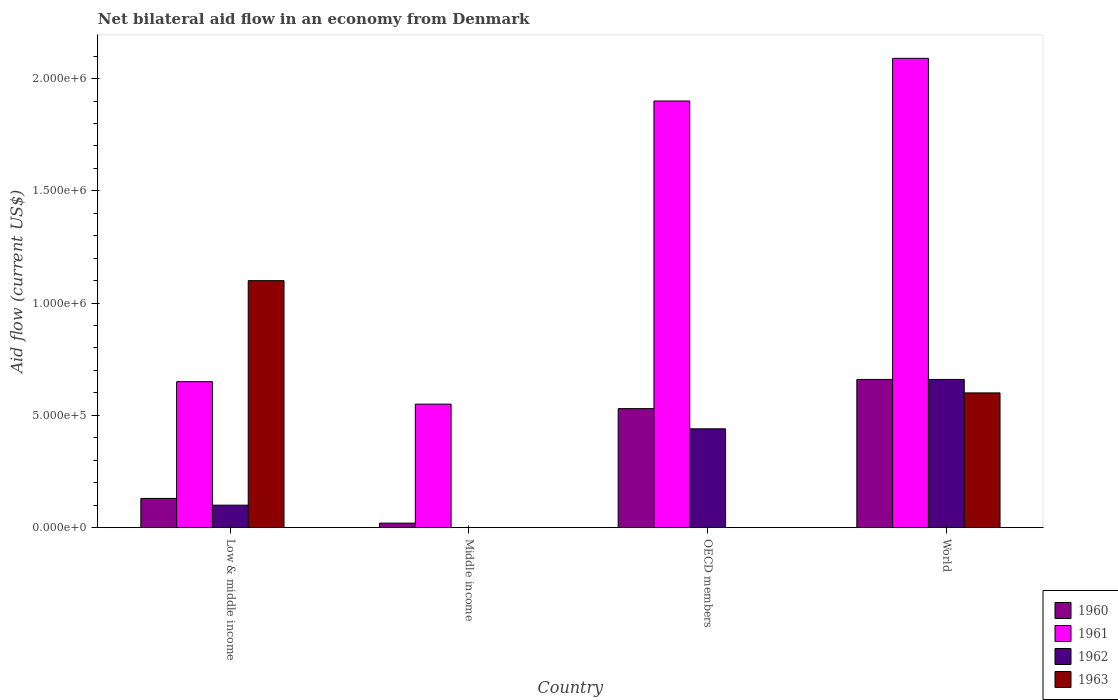Are the number of bars per tick equal to the number of legend labels?
Make the answer very short. No. How many bars are there on the 2nd tick from the right?
Provide a succinct answer. 3. In how many cases, is the number of bars for a given country not equal to the number of legend labels?
Your answer should be compact. 2. What is the net bilateral aid flow in 1960 in Low & middle income?
Offer a very short reply. 1.30e+05. Across all countries, what is the minimum net bilateral aid flow in 1960?
Give a very brief answer. 2.00e+04. In which country was the net bilateral aid flow in 1960 maximum?
Your answer should be very brief. World. What is the total net bilateral aid flow in 1960 in the graph?
Offer a terse response. 1.34e+06. What is the difference between the net bilateral aid flow in 1960 in Middle income and that in OECD members?
Ensure brevity in your answer.  -5.10e+05. What is the difference between the net bilateral aid flow in 1960 in Middle income and the net bilateral aid flow in 1963 in World?
Offer a very short reply. -5.80e+05. What is the average net bilateral aid flow in 1961 per country?
Your response must be concise. 1.30e+06. What is the difference between the net bilateral aid flow of/in 1960 and net bilateral aid flow of/in 1962 in Low & middle income?
Provide a short and direct response. 3.00e+04. In how many countries, is the net bilateral aid flow in 1960 greater than 1200000 US$?
Make the answer very short. 0. What is the ratio of the net bilateral aid flow in 1960 in Low & middle income to that in World?
Your response must be concise. 0.2. Is the net bilateral aid flow in 1960 in Low & middle income less than that in OECD members?
Your answer should be very brief. Yes. What is the difference between the highest and the second highest net bilateral aid flow in 1961?
Provide a succinct answer. 1.44e+06. What is the difference between the highest and the lowest net bilateral aid flow in 1962?
Offer a terse response. 6.60e+05. In how many countries, is the net bilateral aid flow in 1963 greater than the average net bilateral aid flow in 1963 taken over all countries?
Make the answer very short. 2. Is it the case that in every country, the sum of the net bilateral aid flow in 1960 and net bilateral aid flow in 1962 is greater than the sum of net bilateral aid flow in 1961 and net bilateral aid flow in 1963?
Ensure brevity in your answer.  No. Is it the case that in every country, the sum of the net bilateral aid flow in 1961 and net bilateral aid flow in 1960 is greater than the net bilateral aid flow in 1962?
Your answer should be compact. Yes. How many bars are there?
Give a very brief answer. 13. Are all the bars in the graph horizontal?
Ensure brevity in your answer.  No. How many countries are there in the graph?
Offer a terse response. 4. What is the difference between two consecutive major ticks on the Y-axis?
Ensure brevity in your answer.  5.00e+05. What is the title of the graph?
Your response must be concise. Net bilateral aid flow in an economy from Denmark. What is the Aid flow (current US$) in 1960 in Low & middle income?
Make the answer very short. 1.30e+05. What is the Aid flow (current US$) of 1961 in Low & middle income?
Ensure brevity in your answer.  6.50e+05. What is the Aid flow (current US$) in 1962 in Low & middle income?
Make the answer very short. 1.00e+05. What is the Aid flow (current US$) of 1963 in Low & middle income?
Provide a succinct answer. 1.10e+06. What is the Aid flow (current US$) of 1960 in OECD members?
Provide a succinct answer. 5.30e+05. What is the Aid flow (current US$) of 1961 in OECD members?
Offer a terse response. 1.90e+06. What is the Aid flow (current US$) of 1962 in OECD members?
Keep it short and to the point. 4.40e+05. What is the Aid flow (current US$) in 1963 in OECD members?
Your answer should be compact. 0. What is the Aid flow (current US$) in 1961 in World?
Provide a succinct answer. 2.09e+06. Across all countries, what is the maximum Aid flow (current US$) of 1960?
Keep it short and to the point. 6.60e+05. Across all countries, what is the maximum Aid flow (current US$) of 1961?
Your response must be concise. 2.09e+06. Across all countries, what is the maximum Aid flow (current US$) in 1963?
Make the answer very short. 1.10e+06. Across all countries, what is the minimum Aid flow (current US$) of 1960?
Ensure brevity in your answer.  2.00e+04. Across all countries, what is the minimum Aid flow (current US$) in 1961?
Your response must be concise. 5.50e+05. Across all countries, what is the minimum Aid flow (current US$) in 1962?
Provide a short and direct response. 0. Across all countries, what is the minimum Aid flow (current US$) in 1963?
Provide a short and direct response. 0. What is the total Aid flow (current US$) of 1960 in the graph?
Ensure brevity in your answer.  1.34e+06. What is the total Aid flow (current US$) of 1961 in the graph?
Make the answer very short. 5.19e+06. What is the total Aid flow (current US$) in 1962 in the graph?
Provide a succinct answer. 1.20e+06. What is the total Aid flow (current US$) of 1963 in the graph?
Your answer should be very brief. 1.70e+06. What is the difference between the Aid flow (current US$) in 1960 in Low & middle income and that in Middle income?
Your answer should be very brief. 1.10e+05. What is the difference between the Aid flow (current US$) of 1960 in Low & middle income and that in OECD members?
Your answer should be very brief. -4.00e+05. What is the difference between the Aid flow (current US$) of 1961 in Low & middle income and that in OECD members?
Provide a succinct answer. -1.25e+06. What is the difference between the Aid flow (current US$) of 1960 in Low & middle income and that in World?
Offer a very short reply. -5.30e+05. What is the difference between the Aid flow (current US$) in 1961 in Low & middle income and that in World?
Provide a succinct answer. -1.44e+06. What is the difference between the Aid flow (current US$) of 1962 in Low & middle income and that in World?
Provide a succinct answer. -5.60e+05. What is the difference between the Aid flow (current US$) of 1963 in Low & middle income and that in World?
Your answer should be compact. 5.00e+05. What is the difference between the Aid flow (current US$) in 1960 in Middle income and that in OECD members?
Your answer should be very brief. -5.10e+05. What is the difference between the Aid flow (current US$) of 1961 in Middle income and that in OECD members?
Make the answer very short. -1.35e+06. What is the difference between the Aid flow (current US$) in 1960 in Middle income and that in World?
Make the answer very short. -6.40e+05. What is the difference between the Aid flow (current US$) in 1961 in Middle income and that in World?
Provide a short and direct response. -1.54e+06. What is the difference between the Aid flow (current US$) of 1960 in Low & middle income and the Aid flow (current US$) of 1961 in Middle income?
Ensure brevity in your answer.  -4.20e+05. What is the difference between the Aid flow (current US$) in 1960 in Low & middle income and the Aid flow (current US$) in 1961 in OECD members?
Provide a short and direct response. -1.77e+06. What is the difference between the Aid flow (current US$) of 1960 in Low & middle income and the Aid flow (current US$) of 1962 in OECD members?
Your answer should be compact. -3.10e+05. What is the difference between the Aid flow (current US$) in 1961 in Low & middle income and the Aid flow (current US$) in 1962 in OECD members?
Give a very brief answer. 2.10e+05. What is the difference between the Aid flow (current US$) of 1960 in Low & middle income and the Aid flow (current US$) of 1961 in World?
Provide a succinct answer. -1.96e+06. What is the difference between the Aid flow (current US$) in 1960 in Low & middle income and the Aid flow (current US$) in 1962 in World?
Your answer should be compact. -5.30e+05. What is the difference between the Aid flow (current US$) in 1960 in Low & middle income and the Aid flow (current US$) in 1963 in World?
Keep it short and to the point. -4.70e+05. What is the difference between the Aid flow (current US$) in 1962 in Low & middle income and the Aid flow (current US$) in 1963 in World?
Your answer should be compact. -5.00e+05. What is the difference between the Aid flow (current US$) in 1960 in Middle income and the Aid flow (current US$) in 1961 in OECD members?
Your answer should be compact. -1.88e+06. What is the difference between the Aid flow (current US$) in 1960 in Middle income and the Aid flow (current US$) in 1962 in OECD members?
Provide a succinct answer. -4.20e+05. What is the difference between the Aid flow (current US$) of 1961 in Middle income and the Aid flow (current US$) of 1962 in OECD members?
Make the answer very short. 1.10e+05. What is the difference between the Aid flow (current US$) in 1960 in Middle income and the Aid flow (current US$) in 1961 in World?
Your answer should be compact. -2.07e+06. What is the difference between the Aid flow (current US$) in 1960 in Middle income and the Aid flow (current US$) in 1962 in World?
Your answer should be compact. -6.40e+05. What is the difference between the Aid flow (current US$) of 1960 in Middle income and the Aid flow (current US$) of 1963 in World?
Provide a short and direct response. -5.80e+05. What is the difference between the Aid flow (current US$) of 1961 in Middle income and the Aid flow (current US$) of 1963 in World?
Provide a short and direct response. -5.00e+04. What is the difference between the Aid flow (current US$) in 1960 in OECD members and the Aid flow (current US$) in 1961 in World?
Keep it short and to the point. -1.56e+06. What is the difference between the Aid flow (current US$) of 1960 in OECD members and the Aid flow (current US$) of 1962 in World?
Ensure brevity in your answer.  -1.30e+05. What is the difference between the Aid flow (current US$) of 1961 in OECD members and the Aid flow (current US$) of 1962 in World?
Give a very brief answer. 1.24e+06. What is the difference between the Aid flow (current US$) of 1961 in OECD members and the Aid flow (current US$) of 1963 in World?
Your answer should be very brief. 1.30e+06. What is the average Aid flow (current US$) of 1960 per country?
Keep it short and to the point. 3.35e+05. What is the average Aid flow (current US$) in 1961 per country?
Offer a very short reply. 1.30e+06. What is the average Aid flow (current US$) in 1962 per country?
Your answer should be compact. 3.00e+05. What is the average Aid flow (current US$) in 1963 per country?
Your answer should be very brief. 4.25e+05. What is the difference between the Aid flow (current US$) of 1960 and Aid flow (current US$) of 1961 in Low & middle income?
Offer a very short reply. -5.20e+05. What is the difference between the Aid flow (current US$) in 1960 and Aid flow (current US$) in 1963 in Low & middle income?
Your answer should be very brief. -9.70e+05. What is the difference between the Aid flow (current US$) of 1961 and Aid flow (current US$) of 1962 in Low & middle income?
Make the answer very short. 5.50e+05. What is the difference between the Aid flow (current US$) in 1961 and Aid flow (current US$) in 1963 in Low & middle income?
Provide a succinct answer. -4.50e+05. What is the difference between the Aid flow (current US$) of 1960 and Aid flow (current US$) of 1961 in Middle income?
Your answer should be very brief. -5.30e+05. What is the difference between the Aid flow (current US$) of 1960 and Aid flow (current US$) of 1961 in OECD members?
Offer a terse response. -1.37e+06. What is the difference between the Aid flow (current US$) in 1961 and Aid flow (current US$) in 1962 in OECD members?
Give a very brief answer. 1.46e+06. What is the difference between the Aid flow (current US$) of 1960 and Aid flow (current US$) of 1961 in World?
Keep it short and to the point. -1.43e+06. What is the difference between the Aid flow (current US$) in 1960 and Aid flow (current US$) in 1963 in World?
Provide a short and direct response. 6.00e+04. What is the difference between the Aid flow (current US$) of 1961 and Aid flow (current US$) of 1962 in World?
Provide a short and direct response. 1.43e+06. What is the difference between the Aid flow (current US$) of 1961 and Aid flow (current US$) of 1963 in World?
Your response must be concise. 1.49e+06. What is the ratio of the Aid flow (current US$) of 1960 in Low & middle income to that in Middle income?
Keep it short and to the point. 6.5. What is the ratio of the Aid flow (current US$) in 1961 in Low & middle income to that in Middle income?
Your answer should be compact. 1.18. What is the ratio of the Aid flow (current US$) of 1960 in Low & middle income to that in OECD members?
Give a very brief answer. 0.25. What is the ratio of the Aid flow (current US$) in 1961 in Low & middle income to that in OECD members?
Your answer should be compact. 0.34. What is the ratio of the Aid flow (current US$) in 1962 in Low & middle income to that in OECD members?
Your answer should be very brief. 0.23. What is the ratio of the Aid flow (current US$) of 1960 in Low & middle income to that in World?
Give a very brief answer. 0.2. What is the ratio of the Aid flow (current US$) in 1961 in Low & middle income to that in World?
Your answer should be compact. 0.31. What is the ratio of the Aid flow (current US$) in 1962 in Low & middle income to that in World?
Offer a terse response. 0.15. What is the ratio of the Aid flow (current US$) of 1963 in Low & middle income to that in World?
Make the answer very short. 1.83. What is the ratio of the Aid flow (current US$) of 1960 in Middle income to that in OECD members?
Your answer should be very brief. 0.04. What is the ratio of the Aid flow (current US$) in 1961 in Middle income to that in OECD members?
Offer a terse response. 0.29. What is the ratio of the Aid flow (current US$) of 1960 in Middle income to that in World?
Provide a succinct answer. 0.03. What is the ratio of the Aid flow (current US$) of 1961 in Middle income to that in World?
Provide a succinct answer. 0.26. What is the ratio of the Aid flow (current US$) of 1960 in OECD members to that in World?
Give a very brief answer. 0.8. What is the difference between the highest and the lowest Aid flow (current US$) in 1960?
Provide a succinct answer. 6.40e+05. What is the difference between the highest and the lowest Aid flow (current US$) of 1961?
Offer a very short reply. 1.54e+06. What is the difference between the highest and the lowest Aid flow (current US$) of 1963?
Keep it short and to the point. 1.10e+06. 